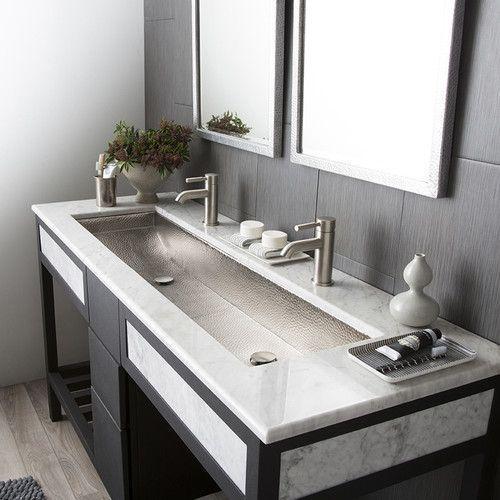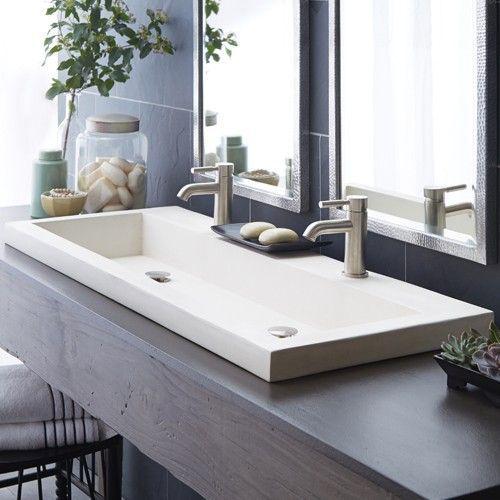The first image is the image on the left, the second image is the image on the right. For the images shown, is this caption "There are two open drawers visible." true? Answer yes or no. No. The first image is the image on the left, the second image is the image on the right. Given the left and right images, does the statement "The bathroom on the left features a freestanding bathtub and a wide rectangular mirror over the sink vanity, and the right image shows a towel on a chrome bar alongside the vanity." hold true? Answer yes or no. No. 